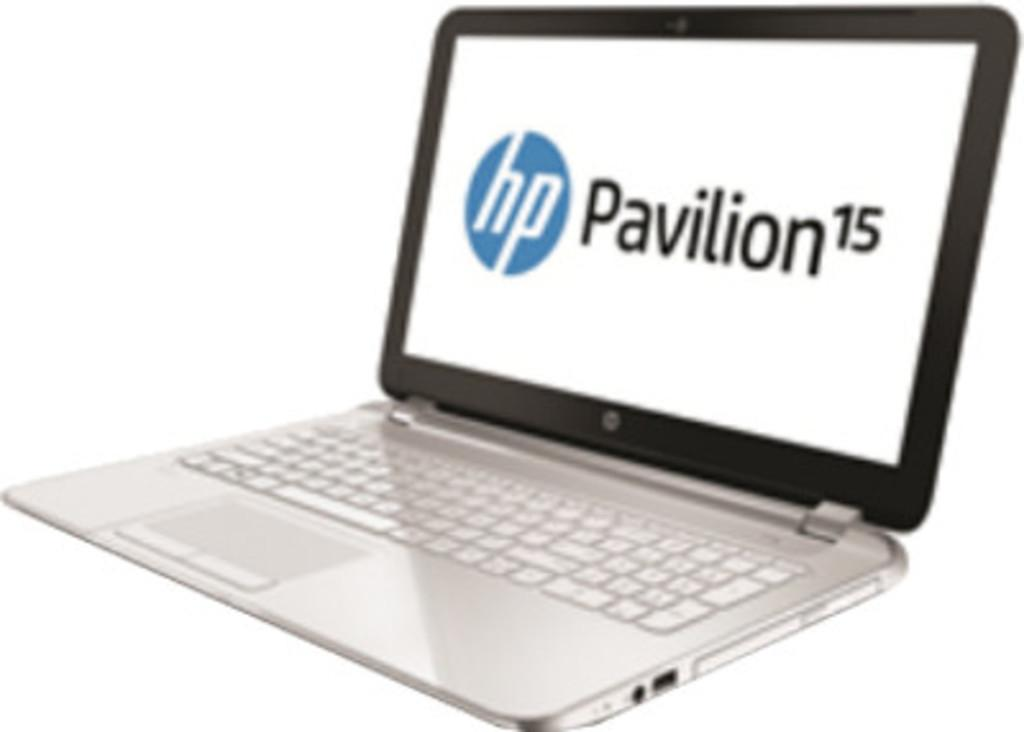<image>
Summarize the visual content of the image. A white laptop with the lid open displays HP Pavilion. 